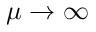<formula> <loc_0><loc_0><loc_500><loc_500>\mu \to \infty</formula> 